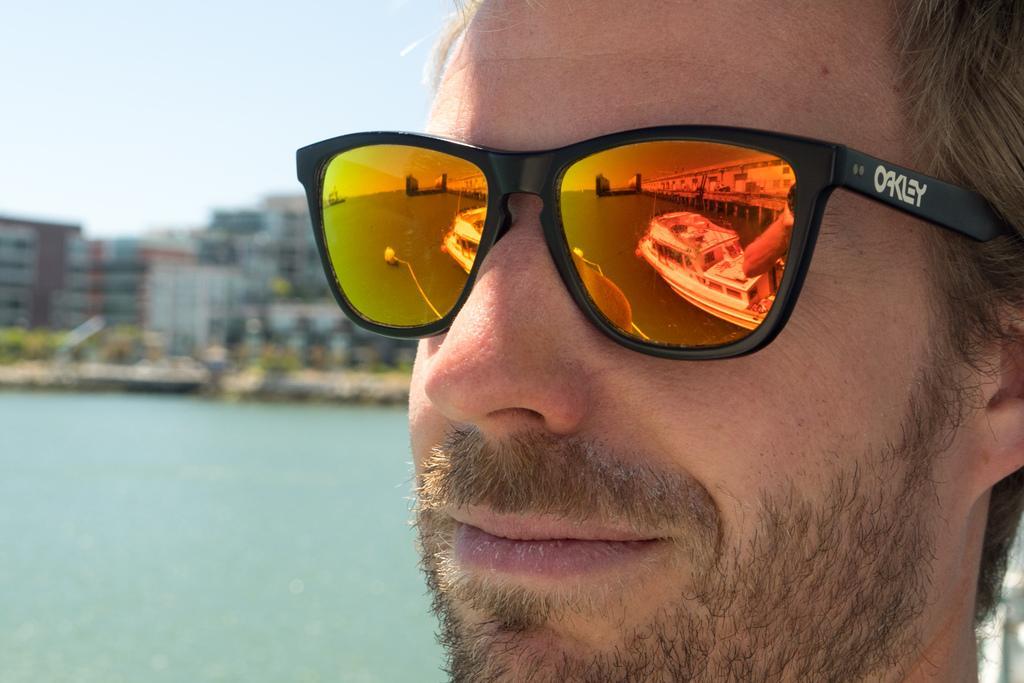Could you give a brief overview of what you see in this image? In this image I can see a person face and he is wearing shades. Back I can see few buildings,trees and water. The sky is in blue and white color. 